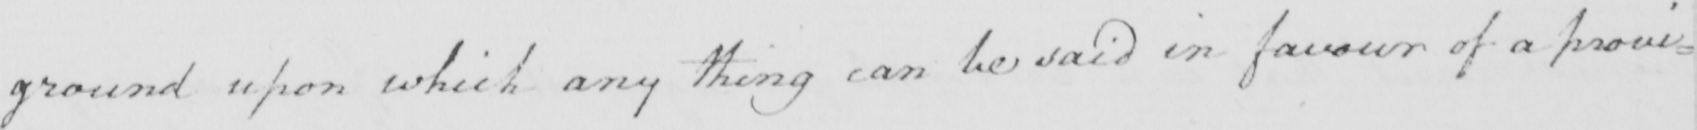What does this handwritten line say? ground upon which any thing can be said in favour of a provi= 